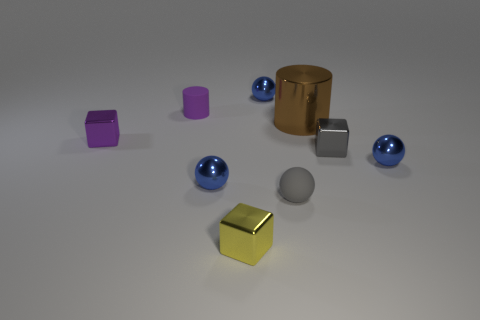What is the material of the block that is the same color as the small rubber sphere?
Make the answer very short. Metal. Are there any blue metal spheres that have the same size as the yellow metal object?
Provide a short and direct response. Yes. What is the color of the tiny thing behind the purple rubber object?
Give a very brief answer. Blue. There is a small metal object behind the brown thing; is there a metallic object that is right of it?
Provide a succinct answer. Yes. How many other objects are the same color as the matte cylinder?
Provide a succinct answer. 1. Is the size of the cylinder that is left of the big brown shiny object the same as the brown cylinder that is behind the small yellow metal cube?
Provide a succinct answer. No. What is the size of the block that is left of the cube in front of the gray shiny cube?
Keep it short and to the point. Small. There is a tiny cube that is both behind the small yellow metallic cube and left of the brown thing; what material is it?
Make the answer very short. Metal. The big metal thing is what color?
Give a very brief answer. Brown. What is the shape of the small rubber thing in front of the brown shiny cylinder?
Keep it short and to the point. Sphere. 